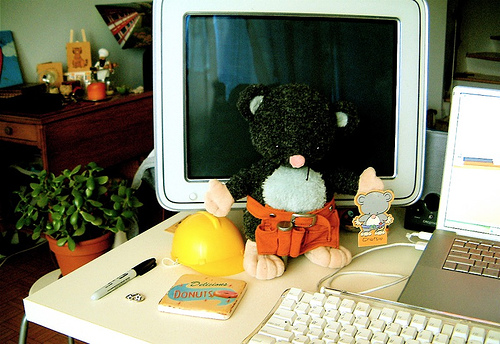<image>
Can you confirm if the plushie is to the right of the laptop? No. The plushie is not to the right of the laptop. The horizontal positioning shows a different relationship. 